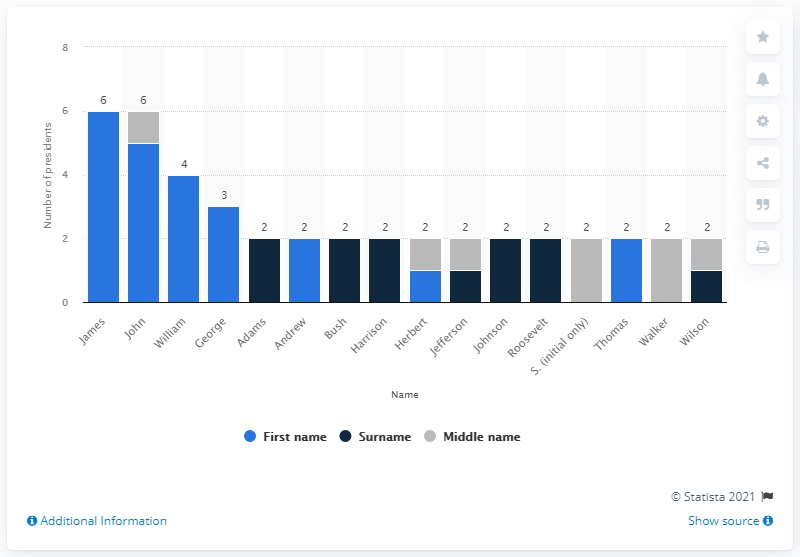What observations can you make about the popularity of certain presidential names over others? From the image, we can observe that traditional, Anglo-Saxon first names such as James, John, and William have been popular among U.S. presidents. It indicates a preference, possibly tied to historical norms and cultural significance. We also see that some names are unique to only one president, which may reflect changes in naming trends or personal namesakes. 